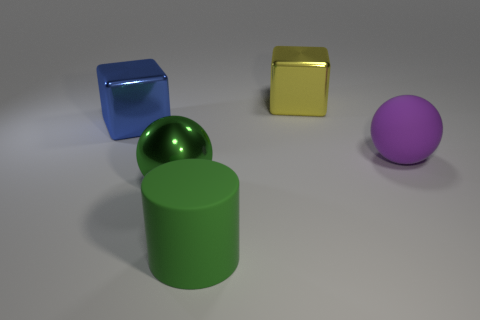Is the size of the rubber thing in front of the green metal object the same as the shiny ball?
Keep it short and to the point. Yes. How many other things are the same shape as the big green matte object?
Your answer should be very brief. 0. What number of gray things are large spheres or big cubes?
Offer a very short reply. 0. Is the color of the object behind the big blue metal object the same as the big cylinder?
Your answer should be very brief. No. What shape is the big green thing that is made of the same material as the blue block?
Offer a terse response. Sphere. What color is the big thing that is both right of the green metallic sphere and in front of the big purple rubber object?
Your answer should be compact. Green. What size is the metal cube that is in front of the large metal block that is behind the big blue thing?
Make the answer very short. Large. Are there any rubber objects of the same color as the cylinder?
Your response must be concise. No. Is the number of blue cubes that are on the right side of the green rubber thing the same as the number of cubes?
Provide a short and direct response. No. How many matte spheres are there?
Your answer should be compact. 1. 